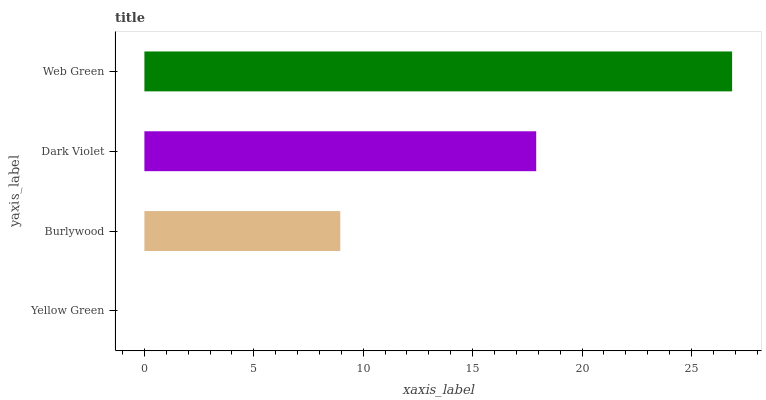Is Yellow Green the minimum?
Answer yes or no. Yes. Is Web Green the maximum?
Answer yes or no. Yes. Is Burlywood the minimum?
Answer yes or no. No. Is Burlywood the maximum?
Answer yes or no. No. Is Burlywood greater than Yellow Green?
Answer yes or no. Yes. Is Yellow Green less than Burlywood?
Answer yes or no. Yes. Is Yellow Green greater than Burlywood?
Answer yes or no. No. Is Burlywood less than Yellow Green?
Answer yes or no. No. Is Dark Violet the high median?
Answer yes or no. Yes. Is Burlywood the low median?
Answer yes or no. Yes. Is Web Green the high median?
Answer yes or no. No. Is Dark Violet the low median?
Answer yes or no. No. 